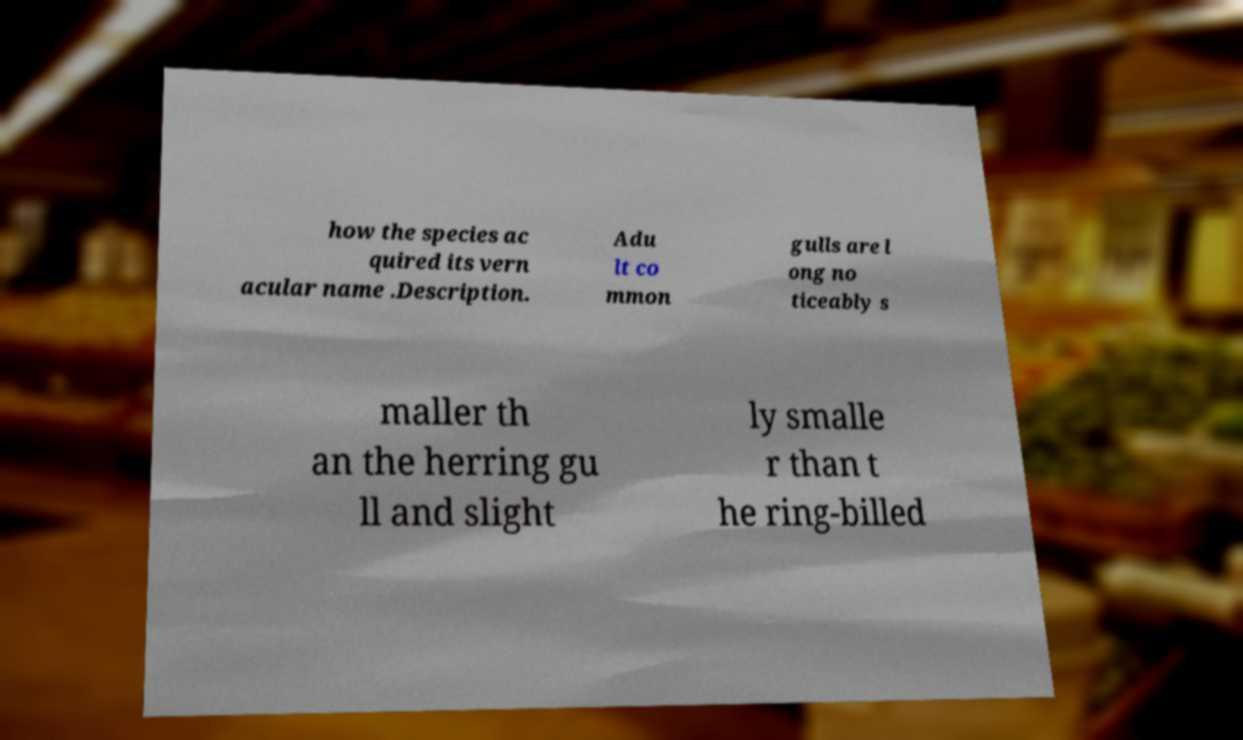There's text embedded in this image that I need extracted. Can you transcribe it verbatim? how the species ac quired its vern acular name .Description. Adu lt co mmon gulls are l ong no ticeably s maller th an the herring gu ll and slight ly smalle r than t he ring-billed 